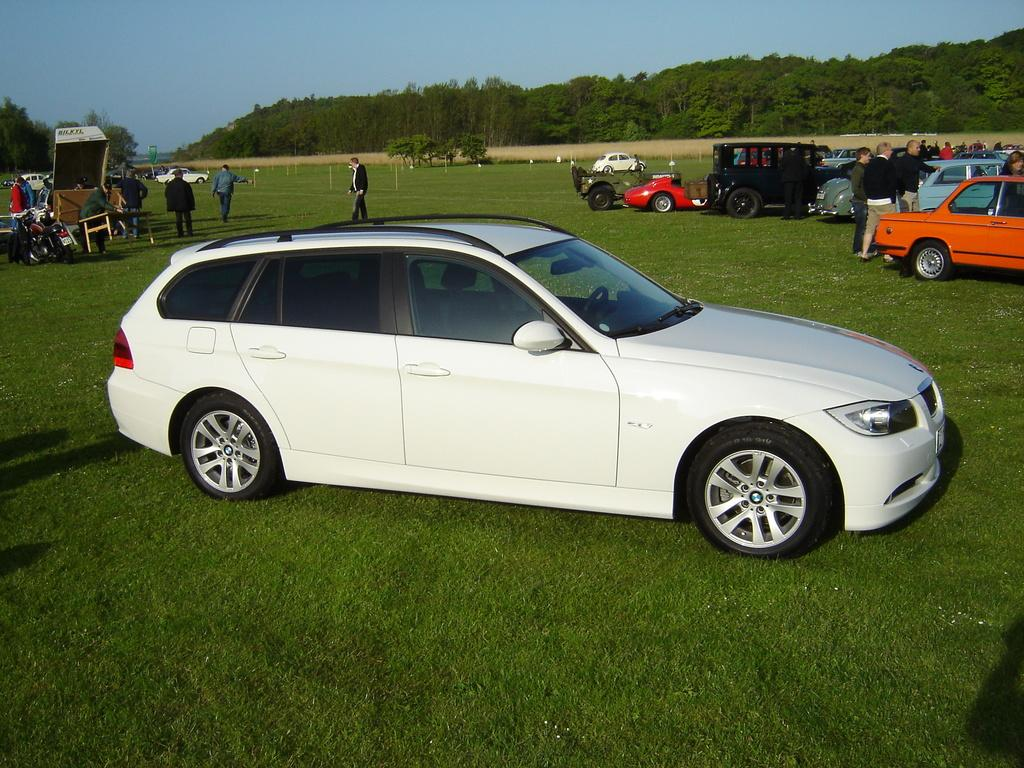What is the main subject in the center of the image? There is a car in the center of the image. What can be seen in the background of the image? There are people standing in the background, as well as trees and the sky. What else is visible on the right side of the image? There are cars and vehicles on the right side of the image. What type of jeans are the snakes wearing in the image? There are no snakes or jeans present in the image. How is the power being generated in the image? There is no mention of power generation in the image; it primarily features a car and its surroundings. 